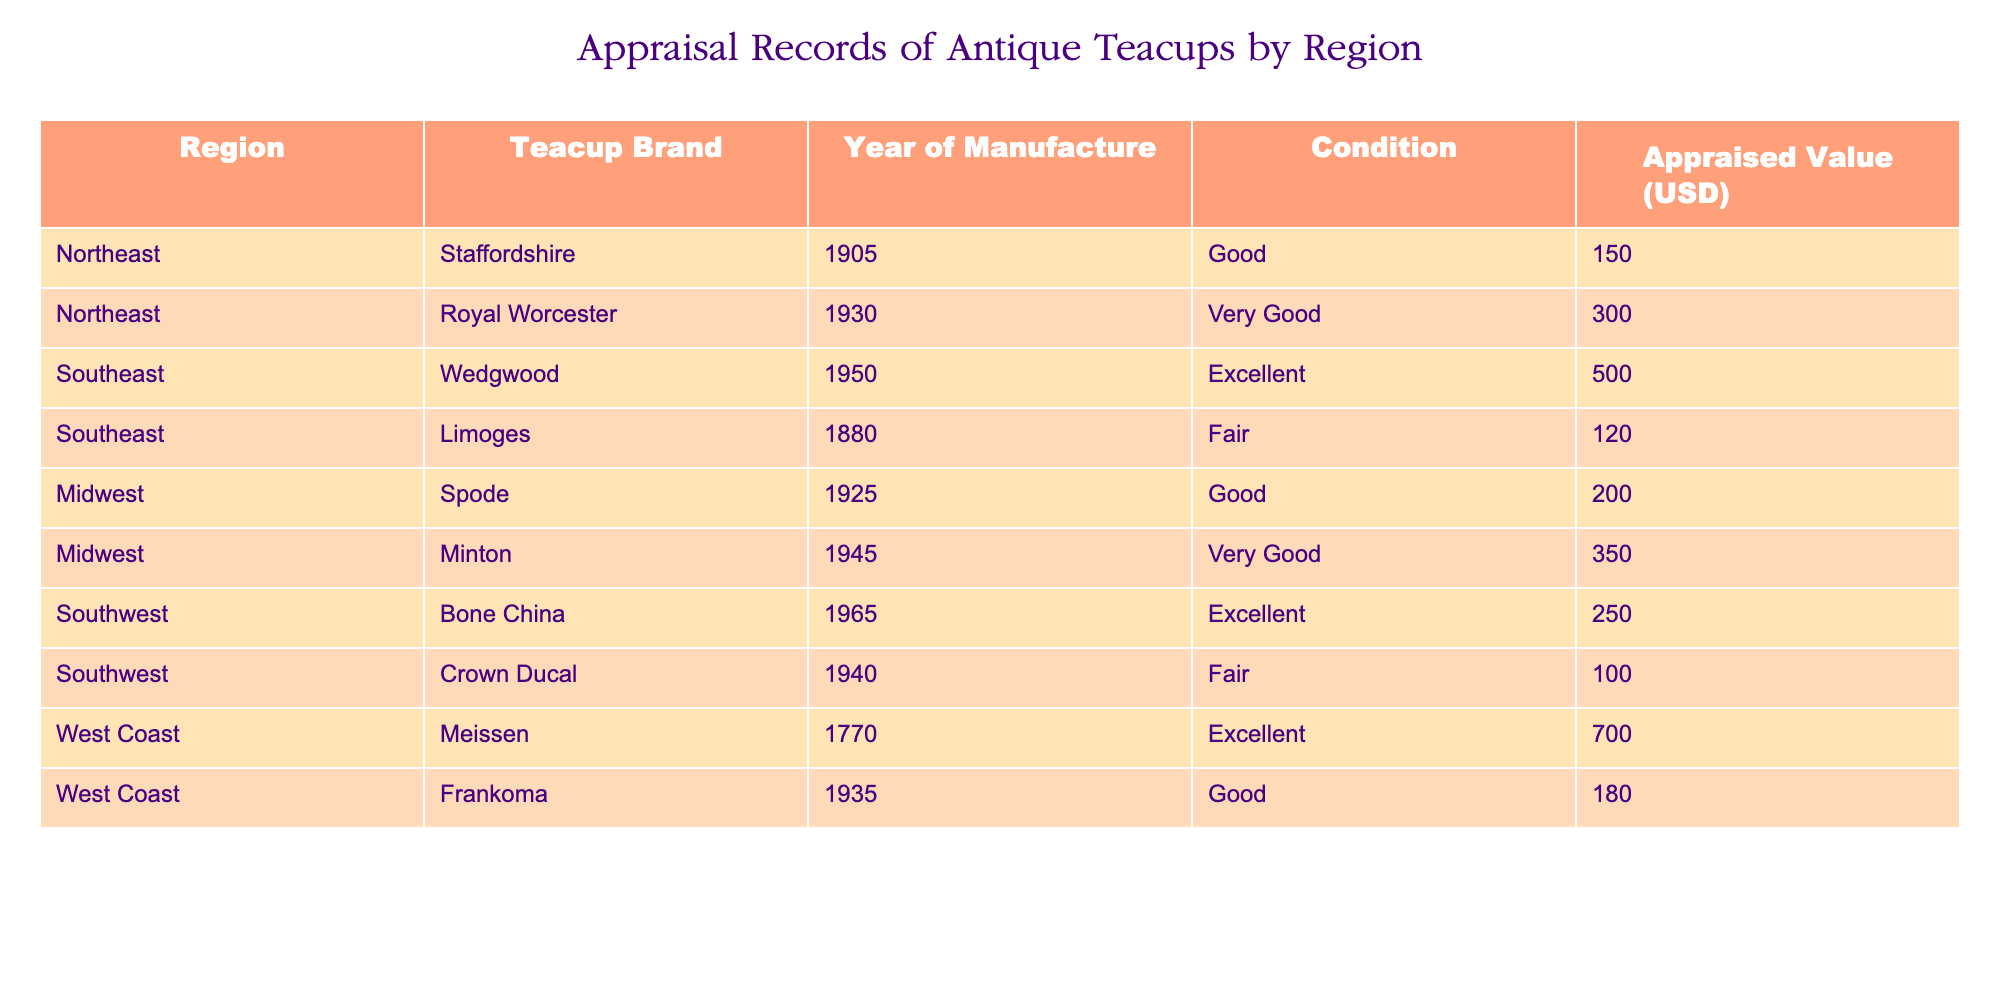What is the appraised value of the Royal Worcester teacup? The table shows that the Royal Worcester, which is listed under the Northeast region, has an appraised value of 300 USD.
Answer: 300 USD Which region has the highest appraised value for its teacups? By examining the appraised values, the West Coast has the highest appraised value teacup, which is the Meissen teacup valued at 700 USD.
Answer: West Coast What is the average appraised value of teacups in the Southeast region? The Southeast region contains two teacups: Wedgwood (500 USD) and Limoges (120 USD). To calculate the average, sum the appraised values (500 + 120 = 620) and divide by the number of teacups (2), resulting in an average of 310 USD.
Answer: 310 USD Is there a teacup manufactured in 1770? The table lists a Meissen teacup that was manufactured in 1770, confirming that there is indeed a teacup with that manufacturing year.
Answer: Yes What is the total appraised value of teacups in the Midwest? The Midwest region includes two teacups: Spode (200 USD) and Minton (350 USD). The total appraised value is calculated by adding these values together (200 + 350 = 550).
Answer: 550 USD Which teacup has the best condition, and what is its value? The table lists the Wedgwood teacup from the Southeast as being in excellent condition with an appraised value of 500 USD.
Answer: Wedgwood, 500 USD Are there any teacups valued at less than 150 USD? Looking through the appraised values, the Crown Ducal teacup from the Southwest is valued at 100 USD, which is less than 150 USD.
Answer: Yes How many teacups are listed as being in "Fair" condition? The table shows two teacups in fair condition: Limoges and Crown Ducal. Therefore, the number of teacups in fair condition is 2.
Answer: 2 